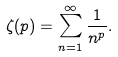Convert formula to latex. <formula><loc_0><loc_0><loc_500><loc_500>\zeta ( p ) = \sum _ { n = 1 } ^ { \infty } \frac { 1 } { n ^ { p } } .</formula> 